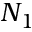Convert formula to latex. <formula><loc_0><loc_0><loc_500><loc_500>N _ { 1 }</formula> 